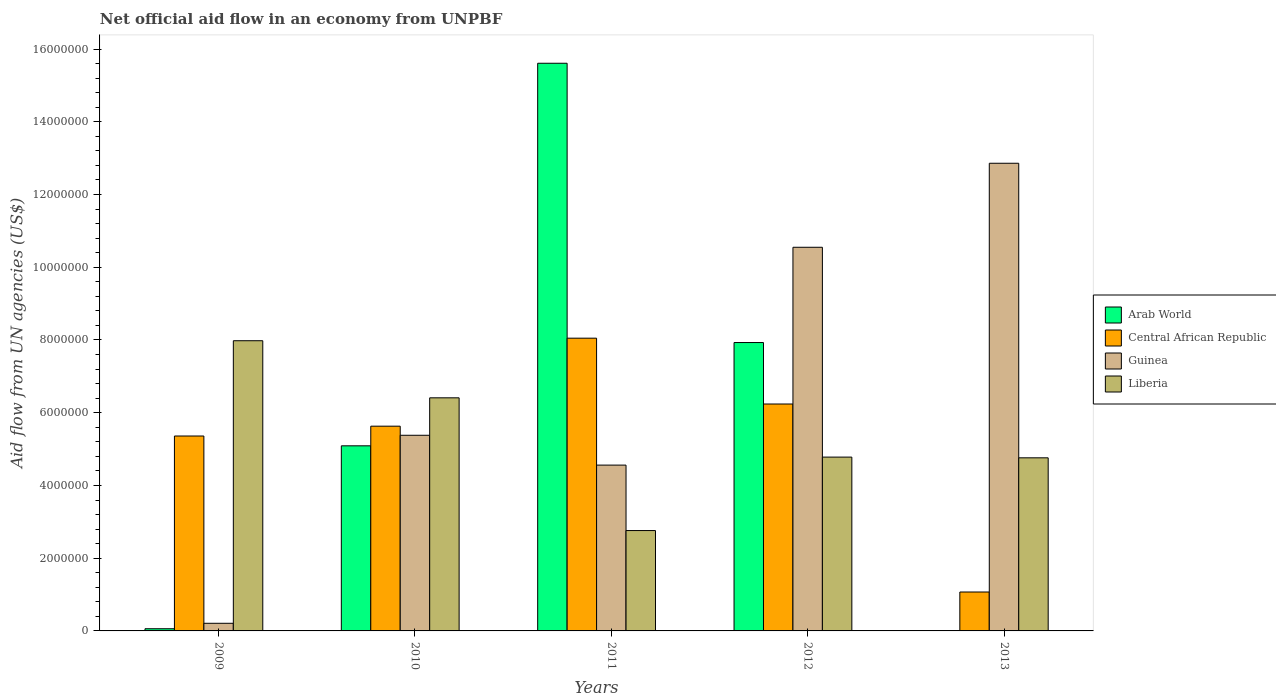How many groups of bars are there?
Give a very brief answer. 5. How many bars are there on the 4th tick from the left?
Offer a terse response. 4. What is the net official aid flow in Guinea in 2013?
Provide a short and direct response. 1.29e+07. Across all years, what is the maximum net official aid flow in Liberia?
Your answer should be compact. 7.98e+06. Across all years, what is the minimum net official aid flow in Central African Republic?
Provide a succinct answer. 1.07e+06. In which year was the net official aid flow in Guinea maximum?
Offer a very short reply. 2013. What is the total net official aid flow in Liberia in the graph?
Your answer should be very brief. 2.67e+07. What is the difference between the net official aid flow in Guinea in 2009 and that in 2011?
Your answer should be compact. -4.35e+06. What is the difference between the net official aid flow in Arab World in 2010 and the net official aid flow in Guinea in 2012?
Offer a very short reply. -5.46e+06. What is the average net official aid flow in Liberia per year?
Provide a short and direct response. 5.34e+06. In the year 2009, what is the difference between the net official aid flow in Central African Republic and net official aid flow in Guinea?
Provide a short and direct response. 5.15e+06. In how many years, is the net official aid flow in Central African Republic greater than 7600000 US$?
Keep it short and to the point. 1. What is the ratio of the net official aid flow in Central African Republic in 2012 to that in 2013?
Offer a terse response. 5.83. Is the net official aid flow in Arab World in 2010 less than that in 2012?
Your answer should be compact. Yes. Is the difference between the net official aid flow in Central African Republic in 2009 and 2010 greater than the difference between the net official aid flow in Guinea in 2009 and 2010?
Your answer should be very brief. Yes. What is the difference between the highest and the second highest net official aid flow in Guinea?
Your answer should be very brief. 2.31e+06. What is the difference between the highest and the lowest net official aid flow in Central African Republic?
Offer a very short reply. 6.98e+06. In how many years, is the net official aid flow in Liberia greater than the average net official aid flow in Liberia taken over all years?
Provide a succinct answer. 2. Is the sum of the net official aid flow in Liberia in 2009 and 2012 greater than the maximum net official aid flow in Central African Republic across all years?
Keep it short and to the point. Yes. Is it the case that in every year, the sum of the net official aid flow in Arab World and net official aid flow in Guinea is greater than the net official aid flow in Central African Republic?
Keep it short and to the point. No. How many bars are there?
Make the answer very short. 19. Are the values on the major ticks of Y-axis written in scientific E-notation?
Ensure brevity in your answer.  No. Does the graph contain grids?
Offer a terse response. No. Where does the legend appear in the graph?
Offer a terse response. Center right. How many legend labels are there?
Your response must be concise. 4. What is the title of the graph?
Your answer should be compact. Net official aid flow in an economy from UNPBF. Does "Heavily indebted poor countries" appear as one of the legend labels in the graph?
Your answer should be compact. No. What is the label or title of the Y-axis?
Provide a short and direct response. Aid flow from UN agencies (US$). What is the Aid flow from UN agencies (US$) of Central African Republic in 2009?
Provide a succinct answer. 5.36e+06. What is the Aid flow from UN agencies (US$) in Liberia in 2009?
Provide a succinct answer. 7.98e+06. What is the Aid flow from UN agencies (US$) of Arab World in 2010?
Your answer should be compact. 5.09e+06. What is the Aid flow from UN agencies (US$) of Central African Republic in 2010?
Your answer should be compact. 5.63e+06. What is the Aid flow from UN agencies (US$) in Guinea in 2010?
Your response must be concise. 5.38e+06. What is the Aid flow from UN agencies (US$) of Liberia in 2010?
Your answer should be very brief. 6.41e+06. What is the Aid flow from UN agencies (US$) in Arab World in 2011?
Keep it short and to the point. 1.56e+07. What is the Aid flow from UN agencies (US$) in Central African Republic in 2011?
Give a very brief answer. 8.05e+06. What is the Aid flow from UN agencies (US$) of Guinea in 2011?
Your answer should be compact. 4.56e+06. What is the Aid flow from UN agencies (US$) of Liberia in 2011?
Offer a terse response. 2.76e+06. What is the Aid flow from UN agencies (US$) in Arab World in 2012?
Provide a short and direct response. 7.93e+06. What is the Aid flow from UN agencies (US$) in Central African Republic in 2012?
Your answer should be compact. 6.24e+06. What is the Aid flow from UN agencies (US$) in Guinea in 2012?
Your response must be concise. 1.06e+07. What is the Aid flow from UN agencies (US$) of Liberia in 2012?
Your answer should be very brief. 4.78e+06. What is the Aid flow from UN agencies (US$) in Arab World in 2013?
Provide a short and direct response. 0. What is the Aid flow from UN agencies (US$) in Central African Republic in 2013?
Ensure brevity in your answer.  1.07e+06. What is the Aid flow from UN agencies (US$) in Guinea in 2013?
Your response must be concise. 1.29e+07. What is the Aid flow from UN agencies (US$) of Liberia in 2013?
Give a very brief answer. 4.76e+06. Across all years, what is the maximum Aid flow from UN agencies (US$) in Arab World?
Ensure brevity in your answer.  1.56e+07. Across all years, what is the maximum Aid flow from UN agencies (US$) of Central African Republic?
Your answer should be compact. 8.05e+06. Across all years, what is the maximum Aid flow from UN agencies (US$) of Guinea?
Make the answer very short. 1.29e+07. Across all years, what is the maximum Aid flow from UN agencies (US$) of Liberia?
Ensure brevity in your answer.  7.98e+06. Across all years, what is the minimum Aid flow from UN agencies (US$) in Arab World?
Offer a terse response. 0. Across all years, what is the minimum Aid flow from UN agencies (US$) in Central African Republic?
Offer a terse response. 1.07e+06. Across all years, what is the minimum Aid flow from UN agencies (US$) of Liberia?
Provide a succinct answer. 2.76e+06. What is the total Aid flow from UN agencies (US$) of Arab World in the graph?
Give a very brief answer. 2.87e+07. What is the total Aid flow from UN agencies (US$) in Central African Republic in the graph?
Keep it short and to the point. 2.64e+07. What is the total Aid flow from UN agencies (US$) of Guinea in the graph?
Make the answer very short. 3.36e+07. What is the total Aid flow from UN agencies (US$) of Liberia in the graph?
Give a very brief answer. 2.67e+07. What is the difference between the Aid flow from UN agencies (US$) of Arab World in 2009 and that in 2010?
Offer a terse response. -5.03e+06. What is the difference between the Aid flow from UN agencies (US$) of Guinea in 2009 and that in 2010?
Provide a succinct answer. -5.17e+06. What is the difference between the Aid flow from UN agencies (US$) of Liberia in 2009 and that in 2010?
Offer a terse response. 1.57e+06. What is the difference between the Aid flow from UN agencies (US$) in Arab World in 2009 and that in 2011?
Ensure brevity in your answer.  -1.56e+07. What is the difference between the Aid flow from UN agencies (US$) of Central African Republic in 2009 and that in 2011?
Make the answer very short. -2.69e+06. What is the difference between the Aid flow from UN agencies (US$) of Guinea in 2009 and that in 2011?
Provide a succinct answer. -4.35e+06. What is the difference between the Aid flow from UN agencies (US$) of Liberia in 2009 and that in 2011?
Offer a very short reply. 5.22e+06. What is the difference between the Aid flow from UN agencies (US$) of Arab World in 2009 and that in 2012?
Offer a terse response. -7.87e+06. What is the difference between the Aid flow from UN agencies (US$) of Central African Republic in 2009 and that in 2012?
Your response must be concise. -8.80e+05. What is the difference between the Aid flow from UN agencies (US$) of Guinea in 2009 and that in 2012?
Your answer should be very brief. -1.03e+07. What is the difference between the Aid flow from UN agencies (US$) of Liberia in 2009 and that in 2012?
Ensure brevity in your answer.  3.20e+06. What is the difference between the Aid flow from UN agencies (US$) of Central African Republic in 2009 and that in 2013?
Make the answer very short. 4.29e+06. What is the difference between the Aid flow from UN agencies (US$) of Guinea in 2009 and that in 2013?
Make the answer very short. -1.26e+07. What is the difference between the Aid flow from UN agencies (US$) of Liberia in 2009 and that in 2013?
Your answer should be compact. 3.22e+06. What is the difference between the Aid flow from UN agencies (US$) of Arab World in 2010 and that in 2011?
Your answer should be very brief. -1.05e+07. What is the difference between the Aid flow from UN agencies (US$) of Central African Republic in 2010 and that in 2011?
Your answer should be compact. -2.42e+06. What is the difference between the Aid flow from UN agencies (US$) in Guinea in 2010 and that in 2011?
Your answer should be compact. 8.20e+05. What is the difference between the Aid flow from UN agencies (US$) of Liberia in 2010 and that in 2011?
Offer a terse response. 3.65e+06. What is the difference between the Aid flow from UN agencies (US$) of Arab World in 2010 and that in 2012?
Ensure brevity in your answer.  -2.84e+06. What is the difference between the Aid flow from UN agencies (US$) in Central African Republic in 2010 and that in 2012?
Ensure brevity in your answer.  -6.10e+05. What is the difference between the Aid flow from UN agencies (US$) in Guinea in 2010 and that in 2012?
Give a very brief answer. -5.17e+06. What is the difference between the Aid flow from UN agencies (US$) in Liberia in 2010 and that in 2012?
Your response must be concise. 1.63e+06. What is the difference between the Aid flow from UN agencies (US$) of Central African Republic in 2010 and that in 2013?
Provide a short and direct response. 4.56e+06. What is the difference between the Aid flow from UN agencies (US$) in Guinea in 2010 and that in 2013?
Provide a short and direct response. -7.48e+06. What is the difference between the Aid flow from UN agencies (US$) of Liberia in 2010 and that in 2013?
Give a very brief answer. 1.65e+06. What is the difference between the Aid flow from UN agencies (US$) in Arab World in 2011 and that in 2012?
Provide a short and direct response. 7.68e+06. What is the difference between the Aid flow from UN agencies (US$) in Central African Republic in 2011 and that in 2012?
Give a very brief answer. 1.81e+06. What is the difference between the Aid flow from UN agencies (US$) in Guinea in 2011 and that in 2012?
Keep it short and to the point. -5.99e+06. What is the difference between the Aid flow from UN agencies (US$) of Liberia in 2011 and that in 2012?
Your answer should be compact. -2.02e+06. What is the difference between the Aid flow from UN agencies (US$) of Central African Republic in 2011 and that in 2013?
Keep it short and to the point. 6.98e+06. What is the difference between the Aid flow from UN agencies (US$) of Guinea in 2011 and that in 2013?
Make the answer very short. -8.30e+06. What is the difference between the Aid flow from UN agencies (US$) of Central African Republic in 2012 and that in 2013?
Ensure brevity in your answer.  5.17e+06. What is the difference between the Aid flow from UN agencies (US$) in Guinea in 2012 and that in 2013?
Your answer should be very brief. -2.31e+06. What is the difference between the Aid flow from UN agencies (US$) in Liberia in 2012 and that in 2013?
Provide a succinct answer. 2.00e+04. What is the difference between the Aid flow from UN agencies (US$) of Arab World in 2009 and the Aid flow from UN agencies (US$) of Central African Republic in 2010?
Make the answer very short. -5.57e+06. What is the difference between the Aid flow from UN agencies (US$) of Arab World in 2009 and the Aid flow from UN agencies (US$) of Guinea in 2010?
Make the answer very short. -5.32e+06. What is the difference between the Aid flow from UN agencies (US$) of Arab World in 2009 and the Aid flow from UN agencies (US$) of Liberia in 2010?
Offer a very short reply. -6.35e+06. What is the difference between the Aid flow from UN agencies (US$) in Central African Republic in 2009 and the Aid flow from UN agencies (US$) in Guinea in 2010?
Your response must be concise. -2.00e+04. What is the difference between the Aid flow from UN agencies (US$) in Central African Republic in 2009 and the Aid flow from UN agencies (US$) in Liberia in 2010?
Your response must be concise. -1.05e+06. What is the difference between the Aid flow from UN agencies (US$) of Guinea in 2009 and the Aid flow from UN agencies (US$) of Liberia in 2010?
Your response must be concise. -6.20e+06. What is the difference between the Aid flow from UN agencies (US$) in Arab World in 2009 and the Aid flow from UN agencies (US$) in Central African Republic in 2011?
Your response must be concise. -7.99e+06. What is the difference between the Aid flow from UN agencies (US$) of Arab World in 2009 and the Aid flow from UN agencies (US$) of Guinea in 2011?
Make the answer very short. -4.50e+06. What is the difference between the Aid flow from UN agencies (US$) of Arab World in 2009 and the Aid flow from UN agencies (US$) of Liberia in 2011?
Offer a terse response. -2.70e+06. What is the difference between the Aid flow from UN agencies (US$) of Central African Republic in 2009 and the Aid flow from UN agencies (US$) of Liberia in 2011?
Give a very brief answer. 2.60e+06. What is the difference between the Aid flow from UN agencies (US$) of Guinea in 2009 and the Aid flow from UN agencies (US$) of Liberia in 2011?
Provide a short and direct response. -2.55e+06. What is the difference between the Aid flow from UN agencies (US$) in Arab World in 2009 and the Aid flow from UN agencies (US$) in Central African Republic in 2012?
Make the answer very short. -6.18e+06. What is the difference between the Aid flow from UN agencies (US$) of Arab World in 2009 and the Aid flow from UN agencies (US$) of Guinea in 2012?
Provide a succinct answer. -1.05e+07. What is the difference between the Aid flow from UN agencies (US$) in Arab World in 2009 and the Aid flow from UN agencies (US$) in Liberia in 2012?
Your answer should be compact. -4.72e+06. What is the difference between the Aid flow from UN agencies (US$) in Central African Republic in 2009 and the Aid flow from UN agencies (US$) in Guinea in 2012?
Provide a succinct answer. -5.19e+06. What is the difference between the Aid flow from UN agencies (US$) in Central African Republic in 2009 and the Aid flow from UN agencies (US$) in Liberia in 2012?
Give a very brief answer. 5.80e+05. What is the difference between the Aid flow from UN agencies (US$) in Guinea in 2009 and the Aid flow from UN agencies (US$) in Liberia in 2012?
Provide a short and direct response. -4.57e+06. What is the difference between the Aid flow from UN agencies (US$) of Arab World in 2009 and the Aid flow from UN agencies (US$) of Central African Republic in 2013?
Offer a terse response. -1.01e+06. What is the difference between the Aid flow from UN agencies (US$) of Arab World in 2009 and the Aid flow from UN agencies (US$) of Guinea in 2013?
Keep it short and to the point. -1.28e+07. What is the difference between the Aid flow from UN agencies (US$) of Arab World in 2009 and the Aid flow from UN agencies (US$) of Liberia in 2013?
Your answer should be very brief. -4.70e+06. What is the difference between the Aid flow from UN agencies (US$) of Central African Republic in 2009 and the Aid flow from UN agencies (US$) of Guinea in 2013?
Provide a short and direct response. -7.50e+06. What is the difference between the Aid flow from UN agencies (US$) of Central African Republic in 2009 and the Aid flow from UN agencies (US$) of Liberia in 2013?
Your response must be concise. 6.00e+05. What is the difference between the Aid flow from UN agencies (US$) of Guinea in 2009 and the Aid flow from UN agencies (US$) of Liberia in 2013?
Your answer should be very brief. -4.55e+06. What is the difference between the Aid flow from UN agencies (US$) of Arab World in 2010 and the Aid flow from UN agencies (US$) of Central African Republic in 2011?
Ensure brevity in your answer.  -2.96e+06. What is the difference between the Aid flow from UN agencies (US$) in Arab World in 2010 and the Aid flow from UN agencies (US$) in Guinea in 2011?
Your response must be concise. 5.30e+05. What is the difference between the Aid flow from UN agencies (US$) of Arab World in 2010 and the Aid flow from UN agencies (US$) of Liberia in 2011?
Offer a very short reply. 2.33e+06. What is the difference between the Aid flow from UN agencies (US$) in Central African Republic in 2010 and the Aid flow from UN agencies (US$) in Guinea in 2011?
Give a very brief answer. 1.07e+06. What is the difference between the Aid flow from UN agencies (US$) in Central African Republic in 2010 and the Aid flow from UN agencies (US$) in Liberia in 2011?
Give a very brief answer. 2.87e+06. What is the difference between the Aid flow from UN agencies (US$) of Guinea in 2010 and the Aid flow from UN agencies (US$) of Liberia in 2011?
Offer a very short reply. 2.62e+06. What is the difference between the Aid flow from UN agencies (US$) in Arab World in 2010 and the Aid flow from UN agencies (US$) in Central African Republic in 2012?
Give a very brief answer. -1.15e+06. What is the difference between the Aid flow from UN agencies (US$) of Arab World in 2010 and the Aid flow from UN agencies (US$) of Guinea in 2012?
Your answer should be compact. -5.46e+06. What is the difference between the Aid flow from UN agencies (US$) in Arab World in 2010 and the Aid flow from UN agencies (US$) in Liberia in 2012?
Your answer should be very brief. 3.10e+05. What is the difference between the Aid flow from UN agencies (US$) of Central African Republic in 2010 and the Aid flow from UN agencies (US$) of Guinea in 2012?
Your answer should be very brief. -4.92e+06. What is the difference between the Aid flow from UN agencies (US$) in Central African Republic in 2010 and the Aid flow from UN agencies (US$) in Liberia in 2012?
Your response must be concise. 8.50e+05. What is the difference between the Aid flow from UN agencies (US$) of Arab World in 2010 and the Aid flow from UN agencies (US$) of Central African Republic in 2013?
Make the answer very short. 4.02e+06. What is the difference between the Aid flow from UN agencies (US$) in Arab World in 2010 and the Aid flow from UN agencies (US$) in Guinea in 2013?
Your answer should be very brief. -7.77e+06. What is the difference between the Aid flow from UN agencies (US$) in Arab World in 2010 and the Aid flow from UN agencies (US$) in Liberia in 2013?
Provide a short and direct response. 3.30e+05. What is the difference between the Aid flow from UN agencies (US$) in Central African Republic in 2010 and the Aid flow from UN agencies (US$) in Guinea in 2013?
Your response must be concise. -7.23e+06. What is the difference between the Aid flow from UN agencies (US$) in Central African Republic in 2010 and the Aid flow from UN agencies (US$) in Liberia in 2013?
Provide a short and direct response. 8.70e+05. What is the difference between the Aid flow from UN agencies (US$) of Guinea in 2010 and the Aid flow from UN agencies (US$) of Liberia in 2013?
Keep it short and to the point. 6.20e+05. What is the difference between the Aid flow from UN agencies (US$) of Arab World in 2011 and the Aid flow from UN agencies (US$) of Central African Republic in 2012?
Provide a short and direct response. 9.37e+06. What is the difference between the Aid flow from UN agencies (US$) in Arab World in 2011 and the Aid flow from UN agencies (US$) in Guinea in 2012?
Ensure brevity in your answer.  5.06e+06. What is the difference between the Aid flow from UN agencies (US$) of Arab World in 2011 and the Aid flow from UN agencies (US$) of Liberia in 2012?
Provide a succinct answer. 1.08e+07. What is the difference between the Aid flow from UN agencies (US$) of Central African Republic in 2011 and the Aid flow from UN agencies (US$) of Guinea in 2012?
Provide a short and direct response. -2.50e+06. What is the difference between the Aid flow from UN agencies (US$) of Central African Republic in 2011 and the Aid flow from UN agencies (US$) of Liberia in 2012?
Keep it short and to the point. 3.27e+06. What is the difference between the Aid flow from UN agencies (US$) in Arab World in 2011 and the Aid flow from UN agencies (US$) in Central African Republic in 2013?
Offer a terse response. 1.45e+07. What is the difference between the Aid flow from UN agencies (US$) of Arab World in 2011 and the Aid flow from UN agencies (US$) of Guinea in 2013?
Your answer should be compact. 2.75e+06. What is the difference between the Aid flow from UN agencies (US$) of Arab World in 2011 and the Aid flow from UN agencies (US$) of Liberia in 2013?
Make the answer very short. 1.08e+07. What is the difference between the Aid flow from UN agencies (US$) of Central African Republic in 2011 and the Aid flow from UN agencies (US$) of Guinea in 2013?
Give a very brief answer. -4.81e+06. What is the difference between the Aid flow from UN agencies (US$) in Central African Republic in 2011 and the Aid flow from UN agencies (US$) in Liberia in 2013?
Provide a short and direct response. 3.29e+06. What is the difference between the Aid flow from UN agencies (US$) in Guinea in 2011 and the Aid flow from UN agencies (US$) in Liberia in 2013?
Your answer should be very brief. -2.00e+05. What is the difference between the Aid flow from UN agencies (US$) of Arab World in 2012 and the Aid flow from UN agencies (US$) of Central African Republic in 2013?
Ensure brevity in your answer.  6.86e+06. What is the difference between the Aid flow from UN agencies (US$) of Arab World in 2012 and the Aid flow from UN agencies (US$) of Guinea in 2013?
Give a very brief answer. -4.93e+06. What is the difference between the Aid flow from UN agencies (US$) of Arab World in 2012 and the Aid flow from UN agencies (US$) of Liberia in 2013?
Provide a short and direct response. 3.17e+06. What is the difference between the Aid flow from UN agencies (US$) in Central African Republic in 2012 and the Aid flow from UN agencies (US$) in Guinea in 2013?
Give a very brief answer. -6.62e+06. What is the difference between the Aid flow from UN agencies (US$) of Central African Republic in 2012 and the Aid flow from UN agencies (US$) of Liberia in 2013?
Your response must be concise. 1.48e+06. What is the difference between the Aid flow from UN agencies (US$) of Guinea in 2012 and the Aid flow from UN agencies (US$) of Liberia in 2013?
Give a very brief answer. 5.79e+06. What is the average Aid flow from UN agencies (US$) in Arab World per year?
Your response must be concise. 5.74e+06. What is the average Aid flow from UN agencies (US$) of Central African Republic per year?
Provide a succinct answer. 5.27e+06. What is the average Aid flow from UN agencies (US$) of Guinea per year?
Ensure brevity in your answer.  6.71e+06. What is the average Aid flow from UN agencies (US$) of Liberia per year?
Your answer should be compact. 5.34e+06. In the year 2009, what is the difference between the Aid flow from UN agencies (US$) of Arab World and Aid flow from UN agencies (US$) of Central African Republic?
Provide a short and direct response. -5.30e+06. In the year 2009, what is the difference between the Aid flow from UN agencies (US$) of Arab World and Aid flow from UN agencies (US$) of Guinea?
Keep it short and to the point. -1.50e+05. In the year 2009, what is the difference between the Aid flow from UN agencies (US$) of Arab World and Aid flow from UN agencies (US$) of Liberia?
Your answer should be compact. -7.92e+06. In the year 2009, what is the difference between the Aid flow from UN agencies (US$) of Central African Republic and Aid flow from UN agencies (US$) of Guinea?
Keep it short and to the point. 5.15e+06. In the year 2009, what is the difference between the Aid flow from UN agencies (US$) in Central African Republic and Aid flow from UN agencies (US$) in Liberia?
Give a very brief answer. -2.62e+06. In the year 2009, what is the difference between the Aid flow from UN agencies (US$) in Guinea and Aid flow from UN agencies (US$) in Liberia?
Offer a very short reply. -7.77e+06. In the year 2010, what is the difference between the Aid flow from UN agencies (US$) in Arab World and Aid flow from UN agencies (US$) in Central African Republic?
Make the answer very short. -5.40e+05. In the year 2010, what is the difference between the Aid flow from UN agencies (US$) in Arab World and Aid flow from UN agencies (US$) in Guinea?
Keep it short and to the point. -2.90e+05. In the year 2010, what is the difference between the Aid flow from UN agencies (US$) of Arab World and Aid flow from UN agencies (US$) of Liberia?
Your answer should be very brief. -1.32e+06. In the year 2010, what is the difference between the Aid flow from UN agencies (US$) of Central African Republic and Aid flow from UN agencies (US$) of Liberia?
Make the answer very short. -7.80e+05. In the year 2010, what is the difference between the Aid flow from UN agencies (US$) in Guinea and Aid flow from UN agencies (US$) in Liberia?
Your answer should be very brief. -1.03e+06. In the year 2011, what is the difference between the Aid flow from UN agencies (US$) of Arab World and Aid flow from UN agencies (US$) of Central African Republic?
Offer a very short reply. 7.56e+06. In the year 2011, what is the difference between the Aid flow from UN agencies (US$) of Arab World and Aid flow from UN agencies (US$) of Guinea?
Provide a succinct answer. 1.10e+07. In the year 2011, what is the difference between the Aid flow from UN agencies (US$) in Arab World and Aid flow from UN agencies (US$) in Liberia?
Offer a terse response. 1.28e+07. In the year 2011, what is the difference between the Aid flow from UN agencies (US$) in Central African Republic and Aid flow from UN agencies (US$) in Guinea?
Your answer should be very brief. 3.49e+06. In the year 2011, what is the difference between the Aid flow from UN agencies (US$) in Central African Republic and Aid flow from UN agencies (US$) in Liberia?
Keep it short and to the point. 5.29e+06. In the year 2011, what is the difference between the Aid flow from UN agencies (US$) of Guinea and Aid flow from UN agencies (US$) of Liberia?
Provide a short and direct response. 1.80e+06. In the year 2012, what is the difference between the Aid flow from UN agencies (US$) of Arab World and Aid flow from UN agencies (US$) of Central African Republic?
Provide a short and direct response. 1.69e+06. In the year 2012, what is the difference between the Aid flow from UN agencies (US$) in Arab World and Aid flow from UN agencies (US$) in Guinea?
Your answer should be very brief. -2.62e+06. In the year 2012, what is the difference between the Aid flow from UN agencies (US$) of Arab World and Aid flow from UN agencies (US$) of Liberia?
Your response must be concise. 3.15e+06. In the year 2012, what is the difference between the Aid flow from UN agencies (US$) in Central African Republic and Aid flow from UN agencies (US$) in Guinea?
Provide a short and direct response. -4.31e+06. In the year 2012, what is the difference between the Aid flow from UN agencies (US$) of Central African Republic and Aid flow from UN agencies (US$) of Liberia?
Your response must be concise. 1.46e+06. In the year 2012, what is the difference between the Aid flow from UN agencies (US$) of Guinea and Aid flow from UN agencies (US$) of Liberia?
Offer a terse response. 5.77e+06. In the year 2013, what is the difference between the Aid flow from UN agencies (US$) of Central African Republic and Aid flow from UN agencies (US$) of Guinea?
Offer a terse response. -1.18e+07. In the year 2013, what is the difference between the Aid flow from UN agencies (US$) of Central African Republic and Aid flow from UN agencies (US$) of Liberia?
Offer a terse response. -3.69e+06. In the year 2013, what is the difference between the Aid flow from UN agencies (US$) in Guinea and Aid flow from UN agencies (US$) in Liberia?
Your response must be concise. 8.10e+06. What is the ratio of the Aid flow from UN agencies (US$) of Arab World in 2009 to that in 2010?
Provide a succinct answer. 0.01. What is the ratio of the Aid flow from UN agencies (US$) in Central African Republic in 2009 to that in 2010?
Offer a terse response. 0.95. What is the ratio of the Aid flow from UN agencies (US$) of Guinea in 2009 to that in 2010?
Offer a very short reply. 0.04. What is the ratio of the Aid flow from UN agencies (US$) of Liberia in 2009 to that in 2010?
Keep it short and to the point. 1.24. What is the ratio of the Aid flow from UN agencies (US$) of Arab World in 2009 to that in 2011?
Your answer should be compact. 0. What is the ratio of the Aid flow from UN agencies (US$) in Central African Republic in 2009 to that in 2011?
Your answer should be very brief. 0.67. What is the ratio of the Aid flow from UN agencies (US$) of Guinea in 2009 to that in 2011?
Give a very brief answer. 0.05. What is the ratio of the Aid flow from UN agencies (US$) of Liberia in 2009 to that in 2011?
Ensure brevity in your answer.  2.89. What is the ratio of the Aid flow from UN agencies (US$) in Arab World in 2009 to that in 2012?
Offer a very short reply. 0.01. What is the ratio of the Aid flow from UN agencies (US$) in Central African Republic in 2009 to that in 2012?
Make the answer very short. 0.86. What is the ratio of the Aid flow from UN agencies (US$) of Guinea in 2009 to that in 2012?
Offer a terse response. 0.02. What is the ratio of the Aid flow from UN agencies (US$) in Liberia in 2009 to that in 2012?
Offer a very short reply. 1.67. What is the ratio of the Aid flow from UN agencies (US$) in Central African Republic in 2009 to that in 2013?
Give a very brief answer. 5.01. What is the ratio of the Aid flow from UN agencies (US$) in Guinea in 2009 to that in 2013?
Provide a succinct answer. 0.02. What is the ratio of the Aid flow from UN agencies (US$) of Liberia in 2009 to that in 2013?
Your answer should be compact. 1.68. What is the ratio of the Aid flow from UN agencies (US$) of Arab World in 2010 to that in 2011?
Offer a terse response. 0.33. What is the ratio of the Aid flow from UN agencies (US$) in Central African Republic in 2010 to that in 2011?
Ensure brevity in your answer.  0.7. What is the ratio of the Aid flow from UN agencies (US$) of Guinea in 2010 to that in 2011?
Make the answer very short. 1.18. What is the ratio of the Aid flow from UN agencies (US$) of Liberia in 2010 to that in 2011?
Your answer should be compact. 2.32. What is the ratio of the Aid flow from UN agencies (US$) of Arab World in 2010 to that in 2012?
Provide a short and direct response. 0.64. What is the ratio of the Aid flow from UN agencies (US$) in Central African Republic in 2010 to that in 2012?
Offer a very short reply. 0.9. What is the ratio of the Aid flow from UN agencies (US$) of Guinea in 2010 to that in 2012?
Your answer should be very brief. 0.51. What is the ratio of the Aid flow from UN agencies (US$) of Liberia in 2010 to that in 2012?
Give a very brief answer. 1.34. What is the ratio of the Aid flow from UN agencies (US$) of Central African Republic in 2010 to that in 2013?
Offer a very short reply. 5.26. What is the ratio of the Aid flow from UN agencies (US$) of Guinea in 2010 to that in 2013?
Give a very brief answer. 0.42. What is the ratio of the Aid flow from UN agencies (US$) in Liberia in 2010 to that in 2013?
Ensure brevity in your answer.  1.35. What is the ratio of the Aid flow from UN agencies (US$) of Arab World in 2011 to that in 2012?
Provide a short and direct response. 1.97. What is the ratio of the Aid flow from UN agencies (US$) in Central African Republic in 2011 to that in 2012?
Your response must be concise. 1.29. What is the ratio of the Aid flow from UN agencies (US$) of Guinea in 2011 to that in 2012?
Provide a short and direct response. 0.43. What is the ratio of the Aid flow from UN agencies (US$) in Liberia in 2011 to that in 2012?
Provide a short and direct response. 0.58. What is the ratio of the Aid flow from UN agencies (US$) in Central African Republic in 2011 to that in 2013?
Provide a succinct answer. 7.52. What is the ratio of the Aid flow from UN agencies (US$) in Guinea in 2011 to that in 2013?
Provide a short and direct response. 0.35. What is the ratio of the Aid flow from UN agencies (US$) in Liberia in 2011 to that in 2013?
Ensure brevity in your answer.  0.58. What is the ratio of the Aid flow from UN agencies (US$) in Central African Republic in 2012 to that in 2013?
Give a very brief answer. 5.83. What is the ratio of the Aid flow from UN agencies (US$) of Guinea in 2012 to that in 2013?
Offer a terse response. 0.82. What is the difference between the highest and the second highest Aid flow from UN agencies (US$) in Arab World?
Offer a very short reply. 7.68e+06. What is the difference between the highest and the second highest Aid flow from UN agencies (US$) of Central African Republic?
Offer a terse response. 1.81e+06. What is the difference between the highest and the second highest Aid flow from UN agencies (US$) in Guinea?
Provide a succinct answer. 2.31e+06. What is the difference between the highest and the second highest Aid flow from UN agencies (US$) in Liberia?
Provide a short and direct response. 1.57e+06. What is the difference between the highest and the lowest Aid flow from UN agencies (US$) in Arab World?
Offer a very short reply. 1.56e+07. What is the difference between the highest and the lowest Aid flow from UN agencies (US$) in Central African Republic?
Make the answer very short. 6.98e+06. What is the difference between the highest and the lowest Aid flow from UN agencies (US$) of Guinea?
Make the answer very short. 1.26e+07. What is the difference between the highest and the lowest Aid flow from UN agencies (US$) in Liberia?
Your response must be concise. 5.22e+06. 